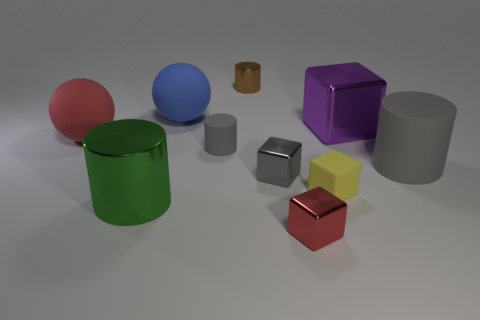Subtract all cyan balls. How many gray cylinders are left? 2 Subtract all red cubes. How many cubes are left? 3 Subtract all green cylinders. How many cylinders are left? 3 Subtract all cylinders. How many objects are left? 6 Add 4 big cylinders. How many big cylinders exist? 6 Subtract 0 red cylinders. How many objects are left? 10 Subtract all blue cylinders. Subtract all cyan balls. How many cylinders are left? 4 Subtract all blue things. Subtract all small cubes. How many objects are left? 6 Add 7 purple metal cubes. How many purple metal cubes are left? 8 